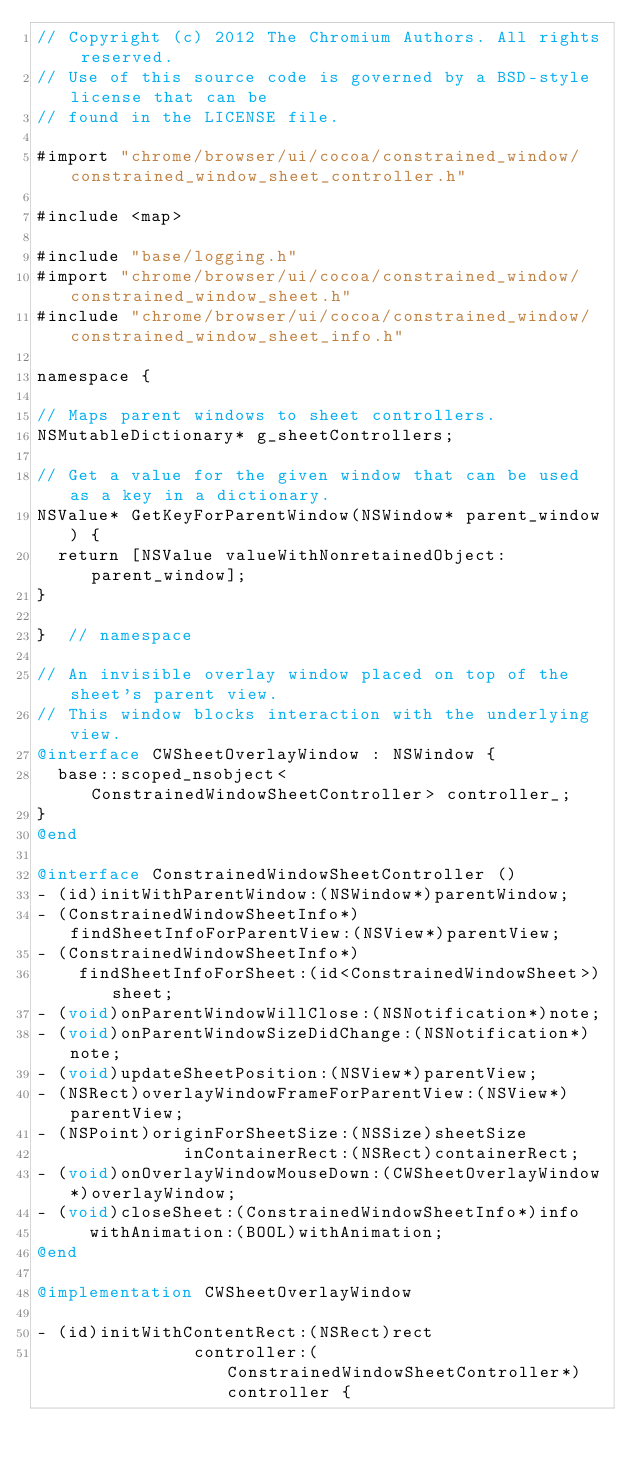Convert code to text. <code><loc_0><loc_0><loc_500><loc_500><_ObjectiveC_>// Copyright (c) 2012 The Chromium Authors. All rights reserved.
// Use of this source code is governed by a BSD-style license that can be
// found in the LICENSE file.

#import "chrome/browser/ui/cocoa/constrained_window/constrained_window_sheet_controller.h"

#include <map>

#include "base/logging.h"
#import "chrome/browser/ui/cocoa/constrained_window/constrained_window_sheet.h"
#include "chrome/browser/ui/cocoa/constrained_window/constrained_window_sheet_info.h"

namespace {

// Maps parent windows to sheet controllers.
NSMutableDictionary* g_sheetControllers;

// Get a value for the given window that can be used as a key in a dictionary.
NSValue* GetKeyForParentWindow(NSWindow* parent_window) {
  return [NSValue valueWithNonretainedObject:parent_window];
}

}  // namespace

// An invisible overlay window placed on top of the sheet's parent view.
// This window blocks interaction with the underlying view.
@interface CWSheetOverlayWindow : NSWindow {
  base::scoped_nsobject<ConstrainedWindowSheetController> controller_;
}
@end

@interface ConstrainedWindowSheetController ()
- (id)initWithParentWindow:(NSWindow*)parentWindow;
- (ConstrainedWindowSheetInfo*)findSheetInfoForParentView:(NSView*)parentView;
- (ConstrainedWindowSheetInfo*)
    findSheetInfoForSheet:(id<ConstrainedWindowSheet>)sheet;
- (void)onParentWindowWillClose:(NSNotification*)note;
- (void)onParentWindowSizeDidChange:(NSNotification*)note;
- (void)updateSheetPosition:(NSView*)parentView;
- (NSRect)overlayWindowFrameForParentView:(NSView*)parentView;
- (NSPoint)originForSheetSize:(NSSize)sheetSize
              inContainerRect:(NSRect)containerRect;
- (void)onOverlayWindowMouseDown:(CWSheetOverlayWindow*)overlayWindow;
- (void)closeSheet:(ConstrainedWindowSheetInfo*)info
     withAnimation:(BOOL)withAnimation;
@end

@implementation CWSheetOverlayWindow

- (id)initWithContentRect:(NSRect)rect
               controller:(ConstrainedWindowSheetController*)controller {</code> 